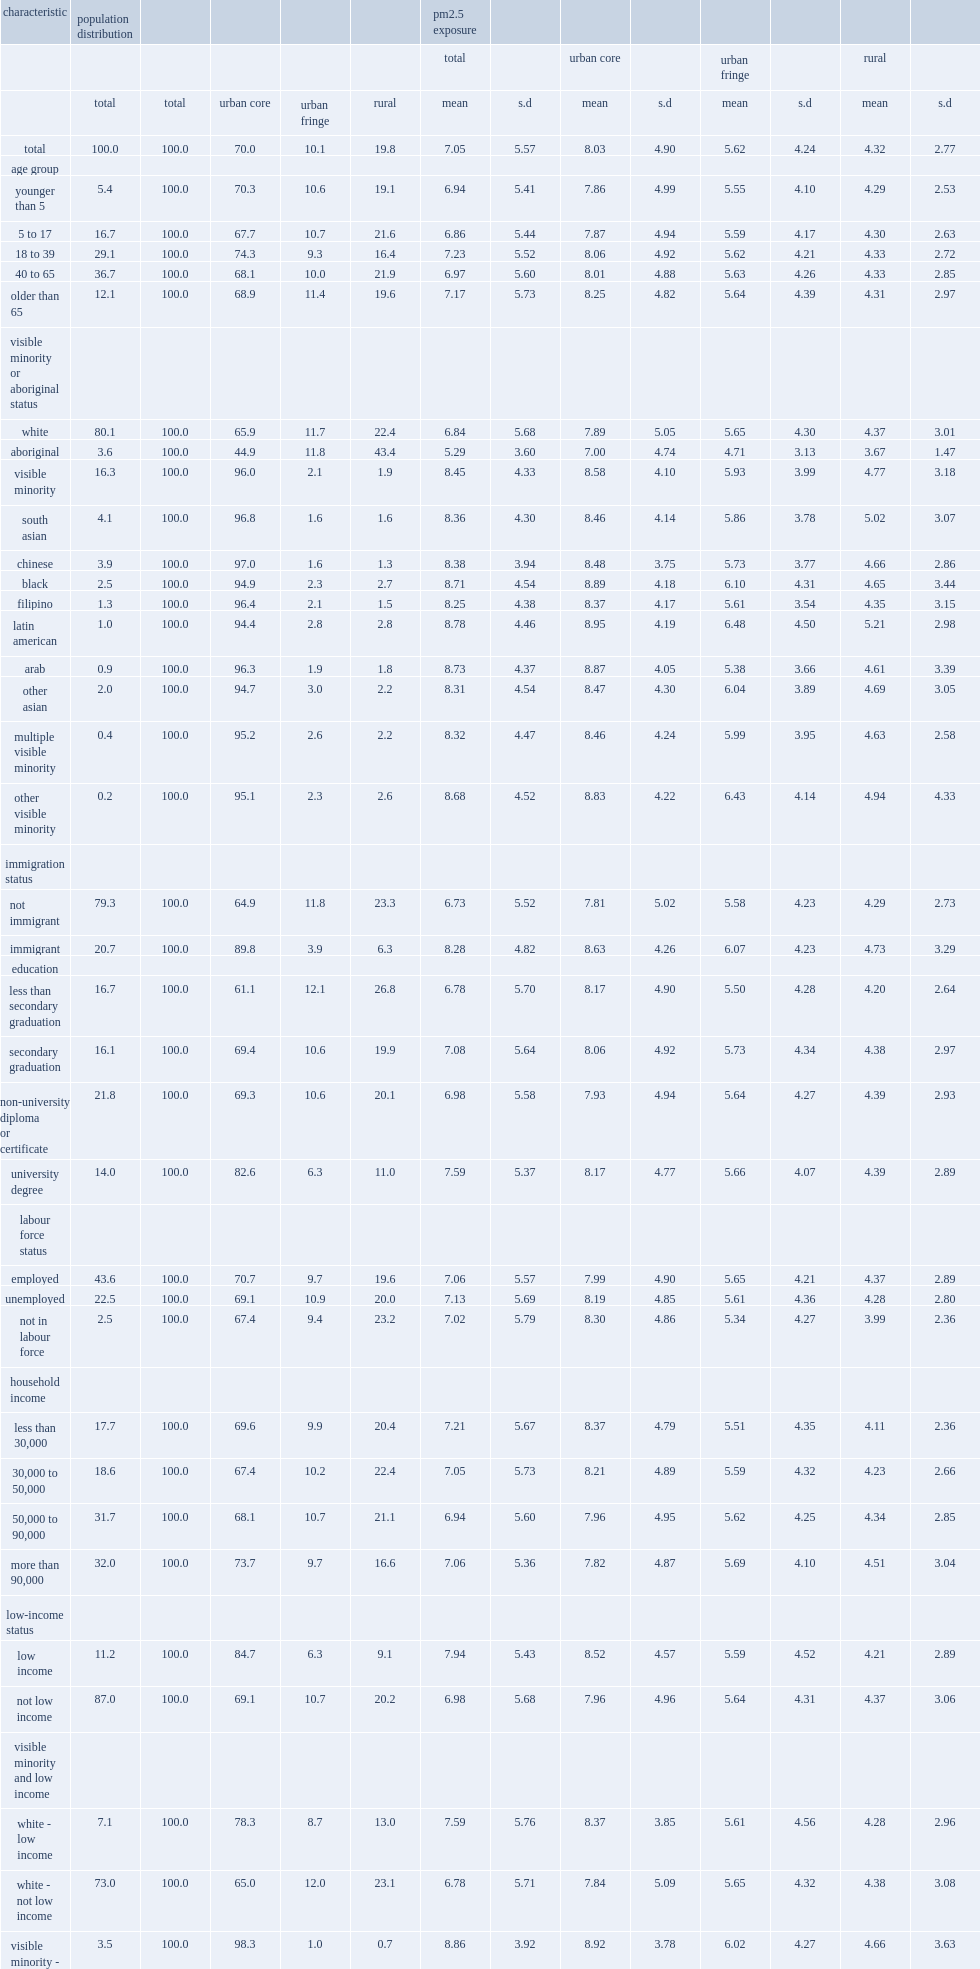What is the urban core estimate pm2.5 exposure? 8.03. What is mean urban fringe pm2.5 exposure? 5.62. What is mean rural pm2.5 exposure? 4.32. How much was the mean exposure of total visible minoriteis to pm2.5 higher than that of the white population? 1.61. What is the percentage of visible minority population who lived in urban cores? 96.0. What is the percentage of white population who lived in urban cores? 65.9. What is the difference between the mean pm2.5 exposure of visible moniority population and that of white population, when only urban cores were considered? 0.69. Which three visible minority or aboriginal status has the highest mean pm2.5 exposures in urban cores? Latin american black arab. How much was the mean pm2.5 exposure among total aboriginal people lower than that for white persons? 1.55. How much was the mean pm2.5 exposure among total immigrants greater than that of non-immigrants? 1.55. What is the difference in mean pm2.5 exposure between immigrants and non-immigrants, among urban core residents? 0.82. In urban cores, which group has a greater mean pm2.5 exposure, people in lower-income households or higher-income household? Low income. In rural areas, which group has a less mean pm2.5 exposure, people in lower-income households or higher-income household? Low income. What is the mean pm2.5 exposure of the total visible minority individuals in low-income households? 8.86. What is the difference between the mean pm2.5 exposure of the total visible minority individuals in low-income households and that of white people who did not live in low-income households? 2.08. 